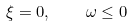<formula> <loc_0><loc_0><loc_500><loc_500>\xi = 0 , \quad \omega \leq 0</formula> 